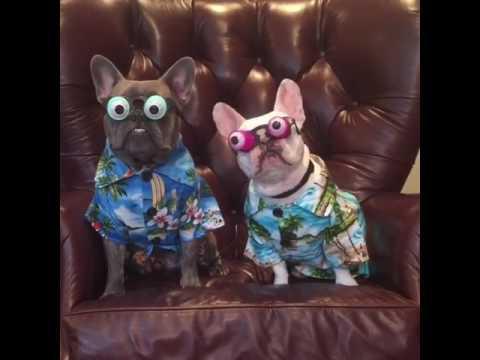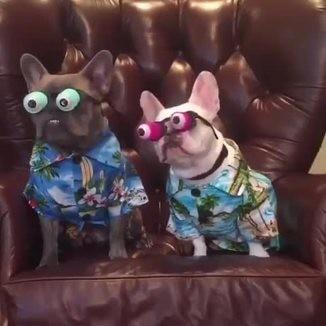The first image is the image on the left, the second image is the image on the right. Considering the images on both sides, is "A dog can be seen sitting on a carpet." valid? Answer yes or no. No. The first image is the image on the left, the second image is the image on the right. Given the left and right images, does the statement "At least two dogs are wearing costumes." hold true? Answer yes or no. Yes. 